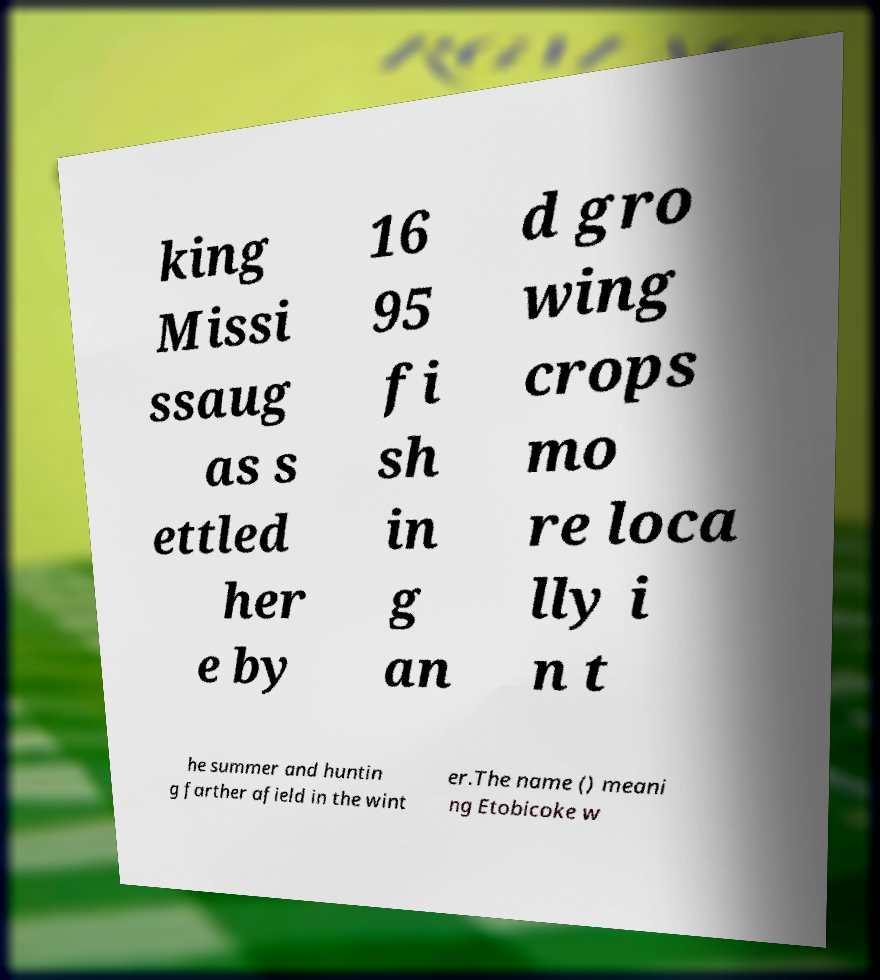There's text embedded in this image that I need extracted. Can you transcribe it verbatim? king Missi ssaug as s ettled her e by 16 95 fi sh in g an d gro wing crops mo re loca lly i n t he summer and huntin g farther afield in the wint er.The name () meani ng Etobicoke w 